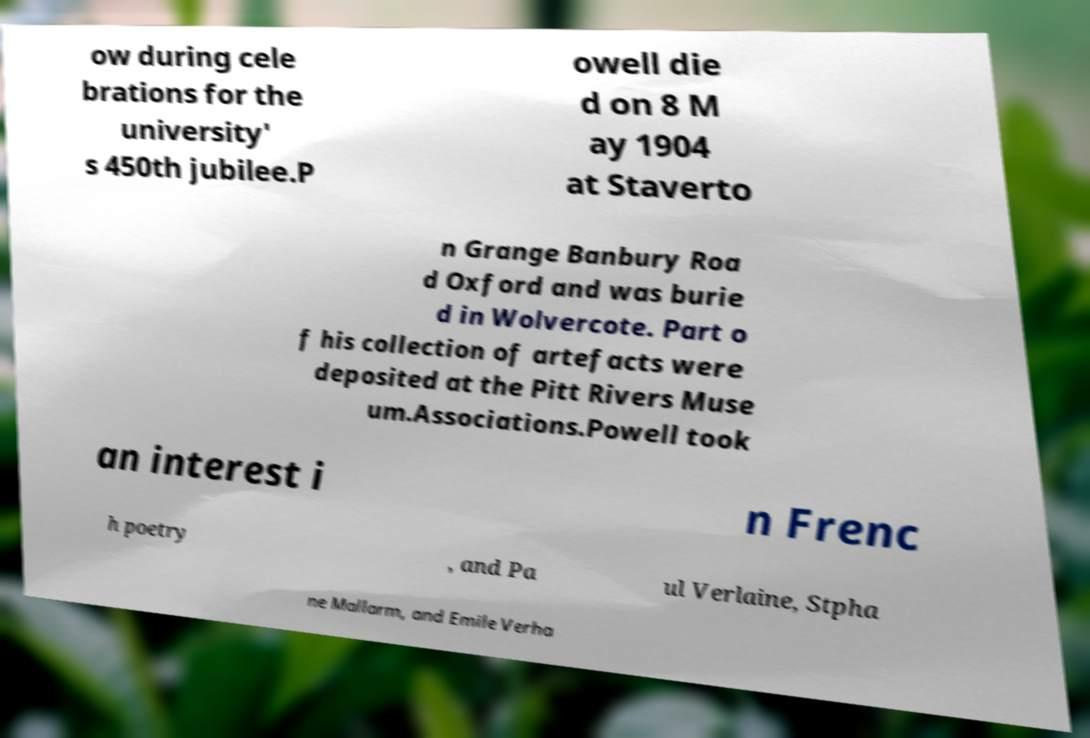Could you extract and type out the text from this image? ow during cele brations for the university' s 450th jubilee.P owell die d on 8 M ay 1904 at Staverto n Grange Banbury Roa d Oxford and was burie d in Wolvercote. Part o f his collection of artefacts were deposited at the Pitt Rivers Muse um.Associations.Powell took an interest i n Frenc h poetry , and Pa ul Verlaine, Stpha ne Mallarm, and Emile Verha 